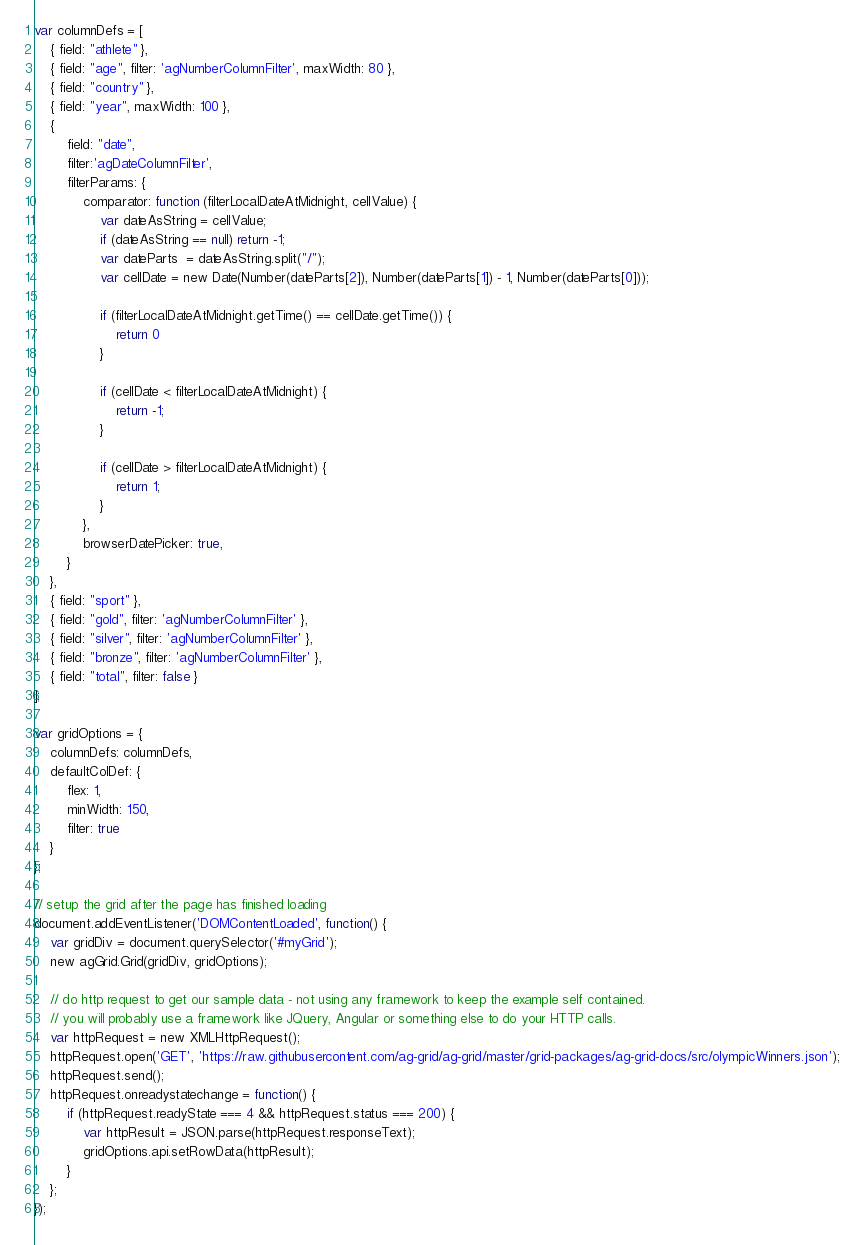Convert code to text. <code><loc_0><loc_0><loc_500><loc_500><_JavaScript_>var columnDefs = [
    { field: "athlete" },
    { field: "age", filter: 'agNumberColumnFilter', maxWidth: 80 },
    { field: "country" },
    { field: "year", maxWidth: 100 },
    {
        field: "date",
        filter:'agDateColumnFilter',
        filterParams: {
            comparator: function (filterLocalDateAtMidnight, cellValue) {
                var dateAsString = cellValue;
                if (dateAsString == null) return -1;
                var dateParts  = dateAsString.split("/");
                var cellDate = new Date(Number(dateParts[2]), Number(dateParts[1]) - 1, Number(dateParts[0]));

                if (filterLocalDateAtMidnight.getTime() == cellDate.getTime()) {
                    return 0
                }

                if (cellDate < filterLocalDateAtMidnight) {
                    return -1;
                }

                if (cellDate > filterLocalDateAtMidnight) {
                    return 1;
                }
            },
            browserDatePicker: true,
        }
    },
    { field: "sport" },
    { field: "gold", filter: 'agNumberColumnFilter' },
    { field: "silver", filter: 'agNumberColumnFilter' },
    { field: "bronze", filter: 'agNumberColumnFilter' },
    { field: "total", filter: false }
];

var gridOptions = {
    columnDefs: columnDefs,
    defaultColDef: {
        flex: 1,
        minWidth: 150,
        filter: true
    }
};

// setup the grid after the page has finished loading
document.addEventListener('DOMContentLoaded', function() {
    var gridDiv = document.querySelector('#myGrid');
    new agGrid.Grid(gridDiv, gridOptions);

    // do http request to get our sample data - not using any framework to keep the example self contained.
    // you will probably use a framework like JQuery, Angular or something else to do your HTTP calls.
    var httpRequest = new XMLHttpRequest();
    httpRequest.open('GET', 'https://raw.githubusercontent.com/ag-grid/ag-grid/master/grid-packages/ag-grid-docs/src/olympicWinners.json');
    httpRequest.send();
    httpRequest.onreadystatechange = function() {
        if (httpRequest.readyState === 4 && httpRequest.status === 200) {
            var httpResult = JSON.parse(httpRequest.responseText);
            gridOptions.api.setRowData(httpResult);
        }
    };
});
</code> 